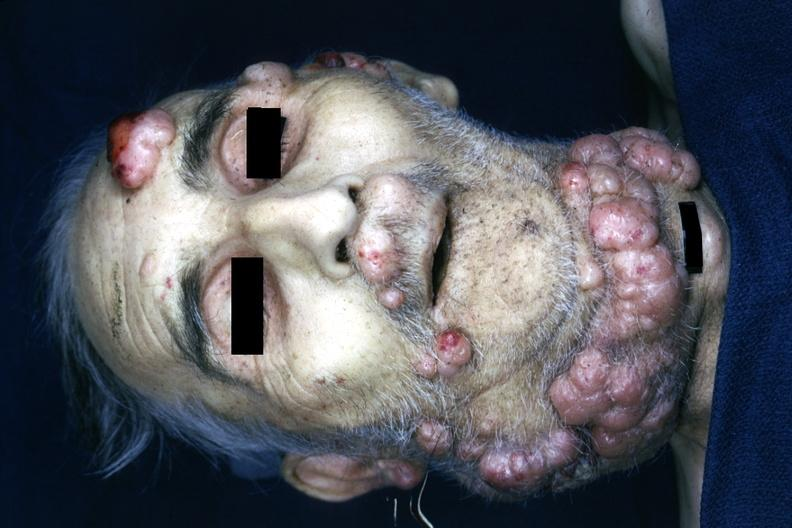s opened muscle present?
Answer the question using a single word or phrase. No 